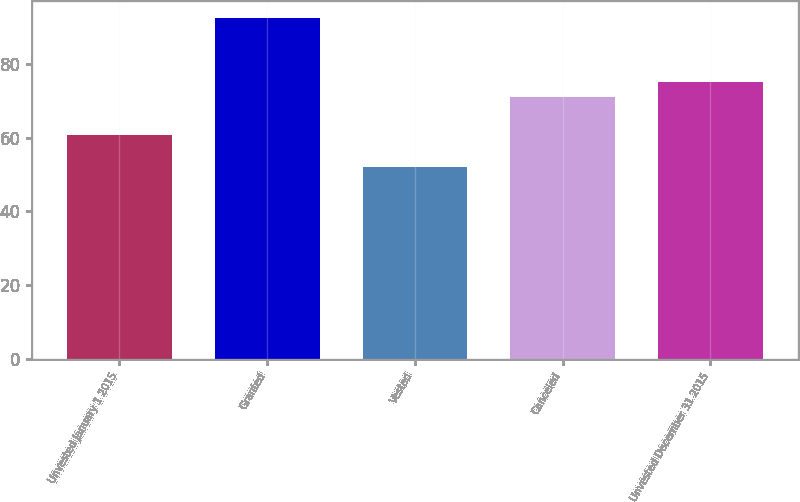Convert chart. <chart><loc_0><loc_0><loc_500><loc_500><bar_chart><fcel>Unvested January 1 2015<fcel>Granted<fcel>Vested<fcel>Canceled<fcel>Unvested December 31 2015<nl><fcel>60.68<fcel>92.44<fcel>52.11<fcel>70.96<fcel>74.99<nl></chart> 